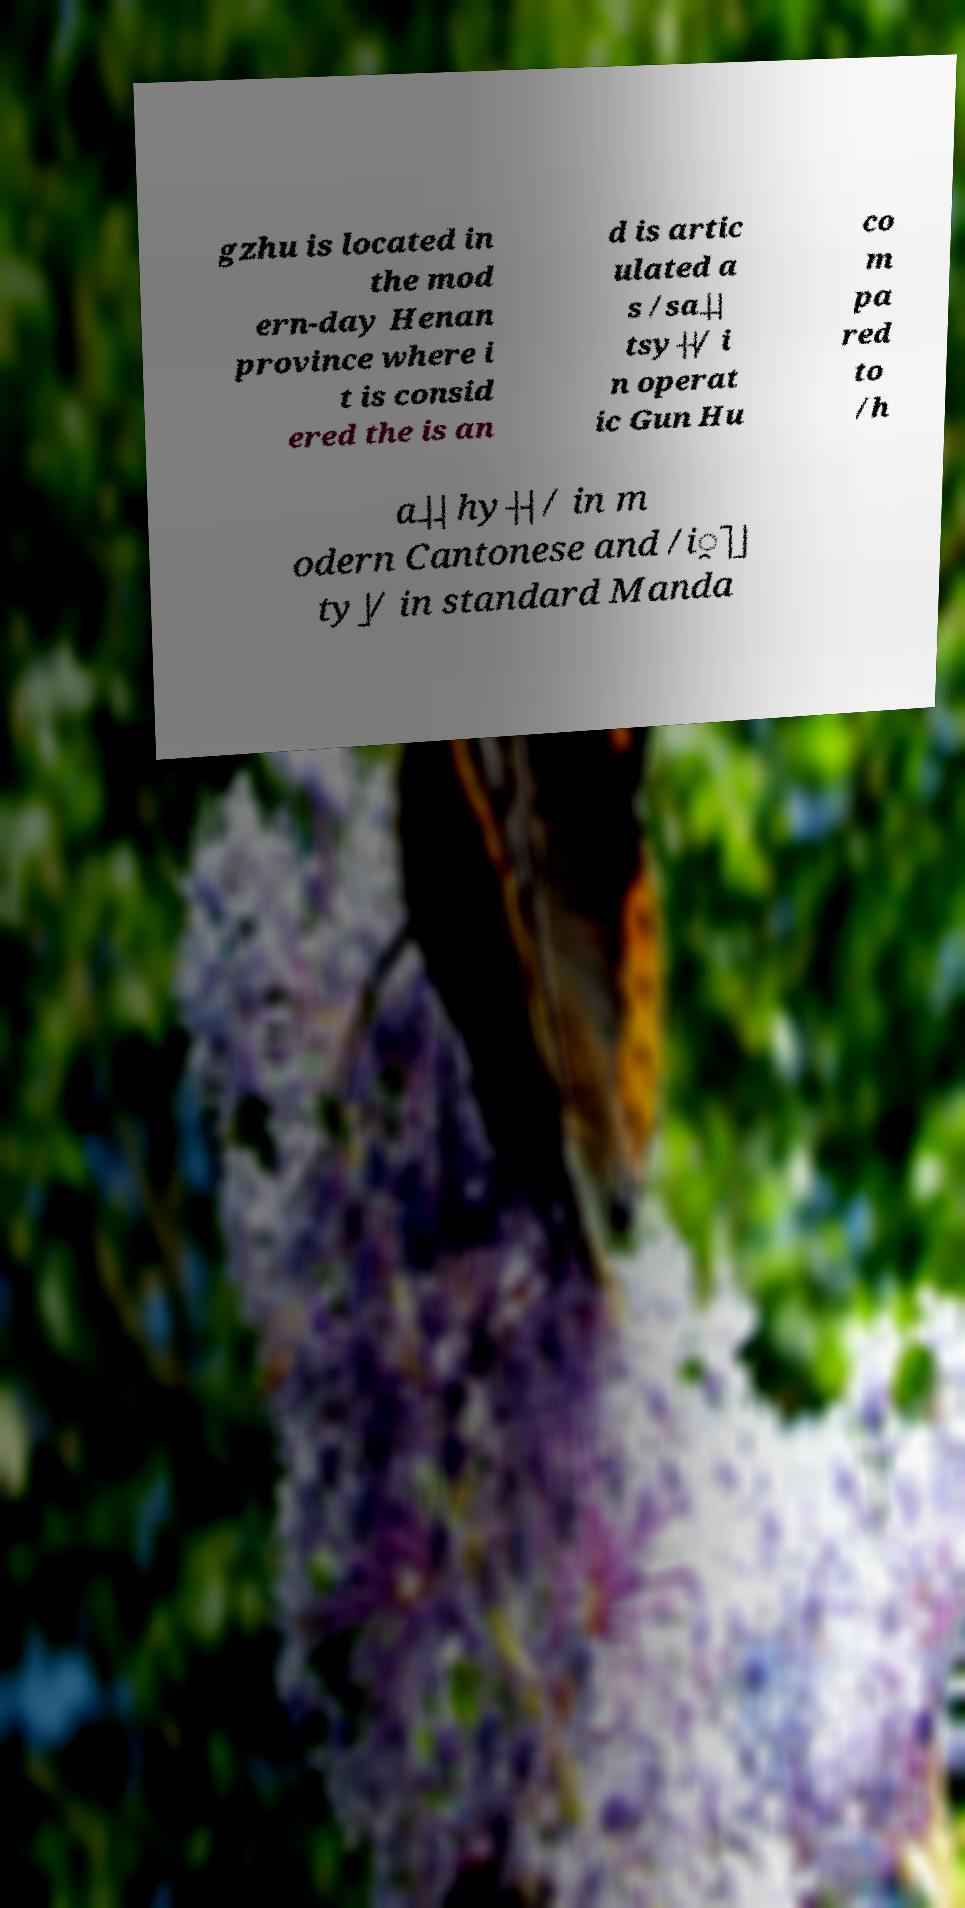Please identify and transcribe the text found in this image. gzhu is located in the mod ern-day Henan province where i t is consid ered the is an d is artic ulated a s /sa˨˨ tsy˧˧/ i n operat ic Gun Hu co m pa red to /h a˨˨ hy˧˧ / in m odern Cantonese and /i̯˥˩ ty˩/ in standard Manda 